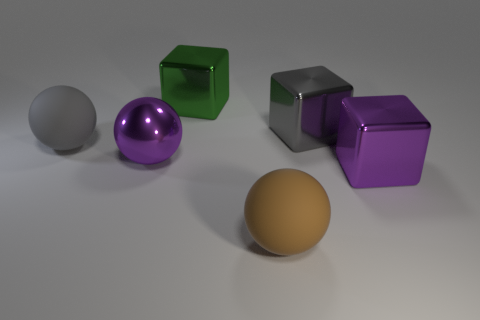Subtract all gray blocks. How many blocks are left? 2 Subtract all big metal balls. How many balls are left? 2 Add 1 big yellow metal balls. How many objects exist? 7 Subtract 2 cubes. How many cubes are left? 1 Add 4 cyan rubber cubes. How many cyan rubber cubes exist? 4 Subtract 1 green cubes. How many objects are left? 5 Subtract all green balls. Subtract all purple cylinders. How many balls are left? 3 Subtract all blue cylinders. How many red blocks are left? 0 Subtract all big gray objects. Subtract all cyan rubber things. How many objects are left? 4 Add 5 brown spheres. How many brown spheres are left? 6 